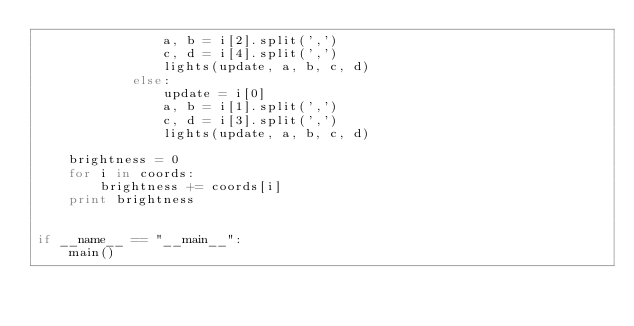<code> <loc_0><loc_0><loc_500><loc_500><_Python_>                a, b = i[2].split(',')
                c, d = i[4].split(',')
                lights(update, a, b, c, d)
            else:
                update = i[0]
                a, b = i[1].split(',')
                c, d = i[3].split(',')
                lights(update, a, b, c, d)

    brightness = 0
    for i in coords:
        brightness += coords[i]
    print brightness


if __name__ == "__main__":
    main()
</code> 